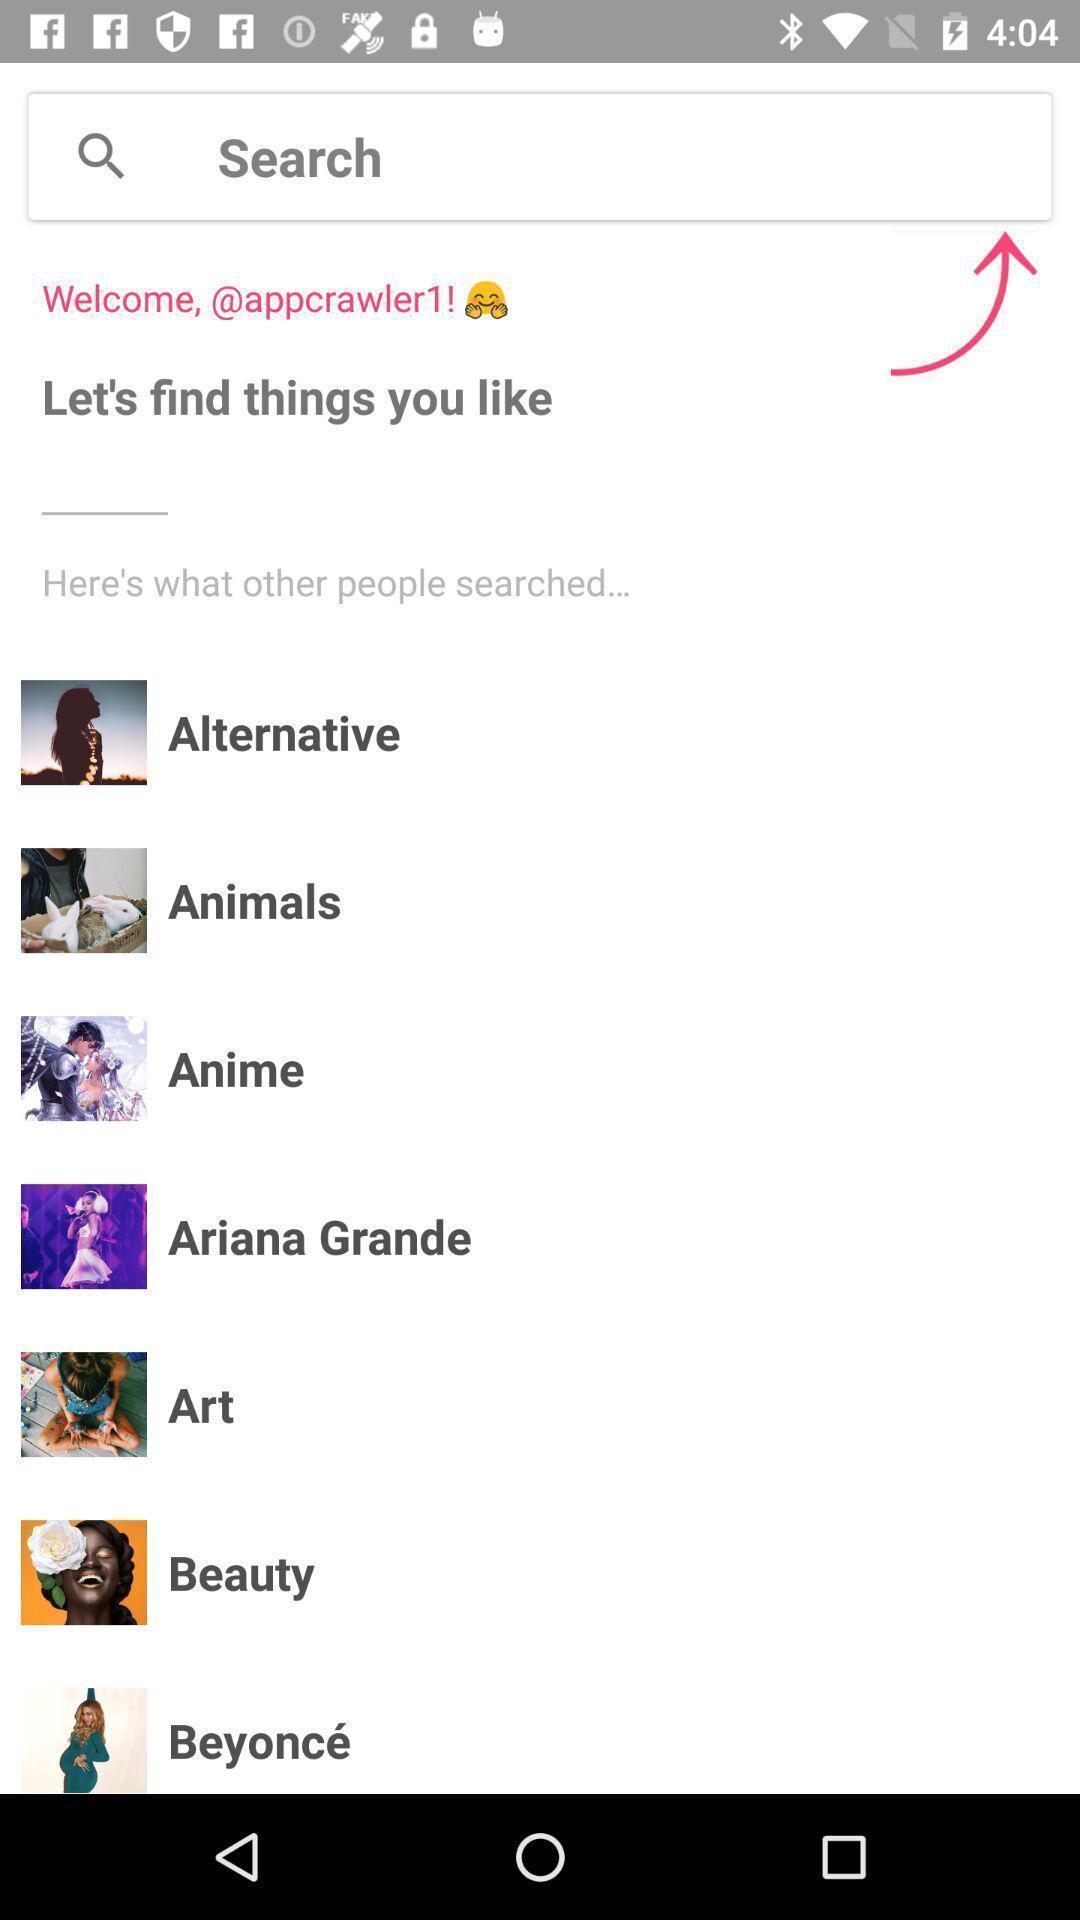Provide a description of this screenshot. Screen shows search page of social media app. 